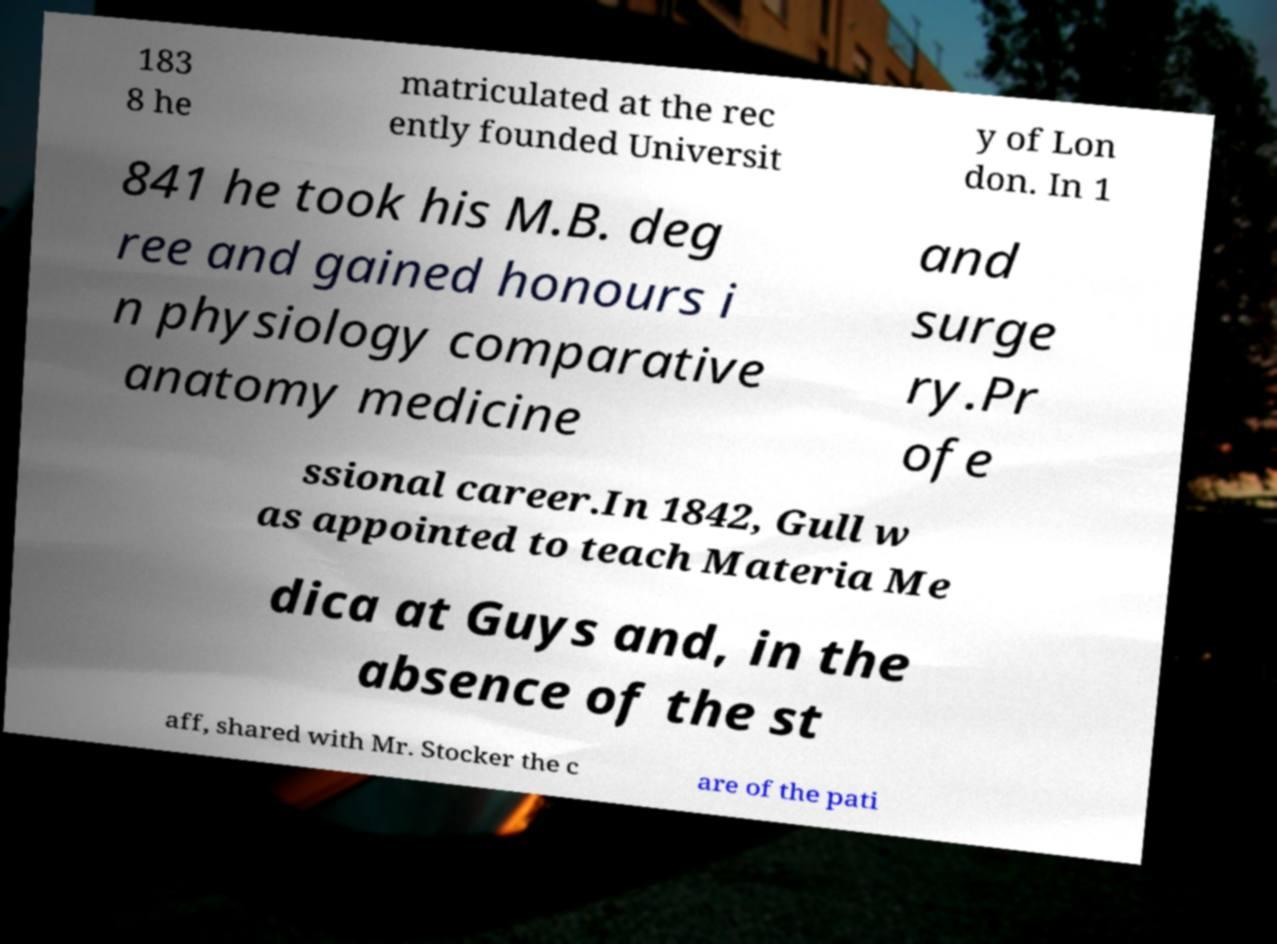I need the written content from this picture converted into text. Can you do that? 183 8 he matriculated at the rec ently founded Universit y of Lon don. In 1 841 he took his M.B. deg ree and gained honours i n physiology comparative anatomy medicine and surge ry.Pr ofe ssional career.In 1842, Gull w as appointed to teach Materia Me dica at Guys and, in the absence of the st aff, shared with Mr. Stocker the c are of the pati 